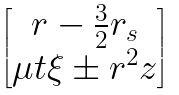Convert formula to latex. <formula><loc_0><loc_0><loc_500><loc_500>\begin{bmatrix} r - \frac { 3 } { 2 } r _ { s } \\ \mu t \xi \pm r ^ { 2 } z \end{bmatrix}</formula> 